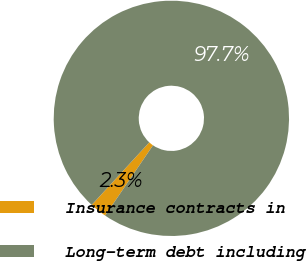Convert chart. <chart><loc_0><loc_0><loc_500><loc_500><pie_chart><fcel>Insurance contracts in<fcel>Long-term debt including<nl><fcel>2.32%<fcel>97.68%<nl></chart> 